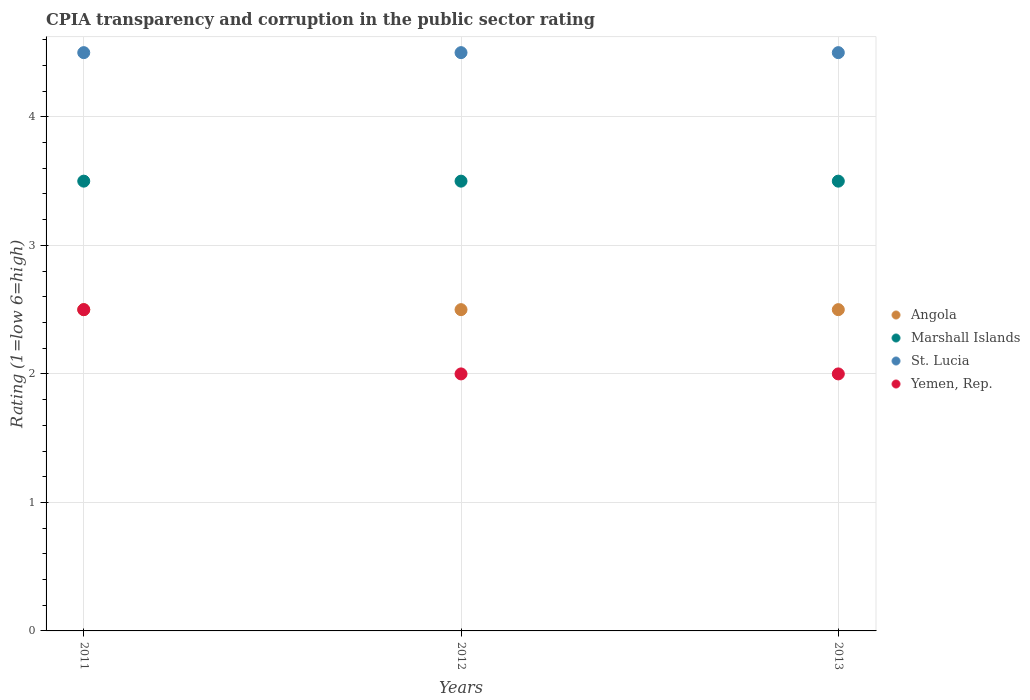How many different coloured dotlines are there?
Keep it short and to the point. 4. What is the CPIA rating in Marshall Islands in 2012?
Offer a terse response. 3.5. Across all years, what is the maximum CPIA rating in St. Lucia?
Give a very brief answer. 4.5. Across all years, what is the minimum CPIA rating in Angola?
Offer a very short reply. 2.5. In which year was the CPIA rating in Marshall Islands maximum?
Provide a succinct answer. 2011. In which year was the CPIA rating in Yemen, Rep. minimum?
Offer a very short reply. 2012. What is the total CPIA rating in St. Lucia in the graph?
Ensure brevity in your answer.  13.5. What is the difference between the CPIA rating in Yemen, Rep. in 2011 and that in 2013?
Your response must be concise. 0.5. What is the difference between the CPIA rating in St. Lucia in 2013 and the CPIA rating in Marshall Islands in 2012?
Your response must be concise. 1. What is the average CPIA rating in Yemen, Rep. per year?
Offer a terse response. 2.17. In how many years, is the CPIA rating in Angola greater than 3.6?
Your response must be concise. 0. Is the difference between the CPIA rating in Angola in 2012 and 2013 greater than the difference between the CPIA rating in St. Lucia in 2012 and 2013?
Keep it short and to the point. No. In how many years, is the CPIA rating in Yemen, Rep. greater than the average CPIA rating in Yemen, Rep. taken over all years?
Your response must be concise. 1. Is it the case that in every year, the sum of the CPIA rating in Yemen, Rep. and CPIA rating in Marshall Islands  is greater than the CPIA rating in St. Lucia?
Keep it short and to the point. Yes. Does the CPIA rating in Angola monotonically increase over the years?
Your answer should be compact. No. How many dotlines are there?
Your response must be concise. 4. What is the difference between two consecutive major ticks on the Y-axis?
Offer a very short reply. 1. Does the graph contain grids?
Give a very brief answer. Yes. Where does the legend appear in the graph?
Keep it short and to the point. Center right. How are the legend labels stacked?
Give a very brief answer. Vertical. What is the title of the graph?
Keep it short and to the point. CPIA transparency and corruption in the public sector rating. Does "Virgin Islands" appear as one of the legend labels in the graph?
Keep it short and to the point. No. What is the label or title of the X-axis?
Offer a terse response. Years. What is the Rating (1=low 6=high) of Angola in 2011?
Offer a terse response. 2.5. What is the Rating (1=low 6=high) in Angola in 2012?
Your response must be concise. 2.5. What is the Rating (1=low 6=high) of Marshall Islands in 2012?
Ensure brevity in your answer.  3.5. What is the Rating (1=low 6=high) in Angola in 2013?
Provide a succinct answer. 2.5. What is the Rating (1=low 6=high) in Marshall Islands in 2013?
Make the answer very short. 3.5. Across all years, what is the maximum Rating (1=low 6=high) in Angola?
Offer a very short reply. 2.5. Across all years, what is the maximum Rating (1=low 6=high) of St. Lucia?
Ensure brevity in your answer.  4.5. Across all years, what is the minimum Rating (1=low 6=high) in Angola?
Give a very brief answer. 2.5. Across all years, what is the minimum Rating (1=low 6=high) of Marshall Islands?
Provide a succinct answer. 3.5. What is the total Rating (1=low 6=high) in Angola in the graph?
Ensure brevity in your answer.  7.5. What is the total Rating (1=low 6=high) of Marshall Islands in the graph?
Your answer should be very brief. 10.5. What is the total Rating (1=low 6=high) of St. Lucia in the graph?
Ensure brevity in your answer.  13.5. What is the difference between the Rating (1=low 6=high) of Marshall Islands in 2011 and that in 2012?
Your response must be concise. 0. What is the difference between the Rating (1=low 6=high) of St. Lucia in 2011 and that in 2012?
Provide a succinct answer. 0. What is the difference between the Rating (1=low 6=high) in Yemen, Rep. in 2011 and that in 2013?
Provide a succinct answer. 0.5. What is the difference between the Rating (1=low 6=high) in Angola in 2012 and that in 2013?
Make the answer very short. 0. What is the difference between the Rating (1=low 6=high) in St. Lucia in 2012 and that in 2013?
Provide a short and direct response. 0. What is the difference between the Rating (1=low 6=high) of Marshall Islands in 2011 and the Rating (1=low 6=high) of St. Lucia in 2012?
Ensure brevity in your answer.  -1. What is the difference between the Rating (1=low 6=high) in St. Lucia in 2011 and the Rating (1=low 6=high) in Yemen, Rep. in 2012?
Keep it short and to the point. 2.5. What is the difference between the Rating (1=low 6=high) of Angola in 2011 and the Rating (1=low 6=high) of Marshall Islands in 2013?
Keep it short and to the point. -1. What is the difference between the Rating (1=low 6=high) of Angola in 2011 and the Rating (1=low 6=high) of St. Lucia in 2013?
Your answer should be compact. -2. What is the difference between the Rating (1=low 6=high) of Marshall Islands in 2011 and the Rating (1=low 6=high) of St. Lucia in 2013?
Make the answer very short. -1. What is the difference between the Rating (1=low 6=high) of Marshall Islands in 2011 and the Rating (1=low 6=high) of Yemen, Rep. in 2013?
Your answer should be compact. 1.5. What is the difference between the Rating (1=low 6=high) in Angola in 2012 and the Rating (1=low 6=high) in Yemen, Rep. in 2013?
Your response must be concise. 0.5. What is the difference between the Rating (1=low 6=high) in Marshall Islands in 2012 and the Rating (1=low 6=high) in St. Lucia in 2013?
Keep it short and to the point. -1. What is the difference between the Rating (1=low 6=high) of St. Lucia in 2012 and the Rating (1=low 6=high) of Yemen, Rep. in 2013?
Provide a succinct answer. 2.5. What is the average Rating (1=low 6=high) of Angola per year?
Offer a terse response. 2.5. What is the average Rating (1=low 6=high) of Marshall Islands per year?
Ensure brevity in your answer.  3.5. What is the average Rating (1=low 6=high) of St. Lucia per year?
Give a very brief answer. 4.5. What is the average Rating (1=low 6=high) of Yemen, Rep. per year?
Your response must be concise. 2.17. In the year 2011, what is the difference between the Rating (1=low 6=high) in Marshall Islands and Rating (1=low 6=high) in St. Lucia?
Provide a short and direct response. -1. In the year 2011, what is the difference between the Rating (1=low 6=high) of Marshall Islands and Rating (1=low 6=high) of Yemen, Rep.?
Your answer should be compact. 1. In the year 2012, what is the difference between the Rating (1=low 6=high) of Angola and Rating (1=low 6=high) of St. Lucia?
Make the answer very short. -2. In the year 2012, what is the difference between the Rating (1=low 6=high) in Angola and Rating (1=low 6=high) in Yemen, Rep.?
Give a very brief answer. 0.5. In the year 2012, what is the difference between the Rating (1=low 6=high) of Marshall Islands and Rating (1=low 6=high) of St. Lucia?
Ensure brevity in your answer.  -1. In the year 2012, what is the difference between the Rating (1=low 6=high) of Marshall Islands and Rating (1=low 6=high) of Yemen, Rep.?
Keep it short and to the point. 1.5. In the year 2012, what is the difference between the Rating (1=low 6=high) of St. Lucia and Rating (1=low 6=high) of Yemen, Rep.?
Provide a short and direct response. 2.5. In the year 2013, what is the difference between the Rating (1=low 6=high) in Angola and Rating (1=low 6=high) in St. Lucia?
Offer a very short reply. -2. What is the ratio of the Rating (1=low 6=high) in Marshall Islands in 2011 to that in 2012?
Make the answer very short. 1. What is the ratio of the Rating (1=low 6=high) in St. Lucia in 2011 to that in 2013?
Ensure brevity in your answer.  1. What is the ratio of the Rating (1=low 6=high) in Angola in 2012 to that in 2013?
Your answer should be compact. 1. What is the ratio of the Rating (1=low 6=high) in Yemen, Rep. in 2012 to that in 2013?
Provide a short and direct response. 1. What is the difference between the highest and the second highest Rating (1=low 6=high) of Angola?
Give a very brief answer. 0. What is the difference between the highest and the second highest Rating (1=low 6=high) of Marshall Islands?
Give a very brief answer. 0. What is the difference between the highest and the second highest Rating (1=low 6=high) of St. Lucia?
Provide a short and direct response. 0. What is the difference between the highest and the second highest Rating (1=low 6=high) of Yemen, Rep.?
Your answer should be compact. 0.5. What is the difference between the highest and the lowest Rating (1=low 6=high) of St. Lucia?
Offer a terse response. 0. 